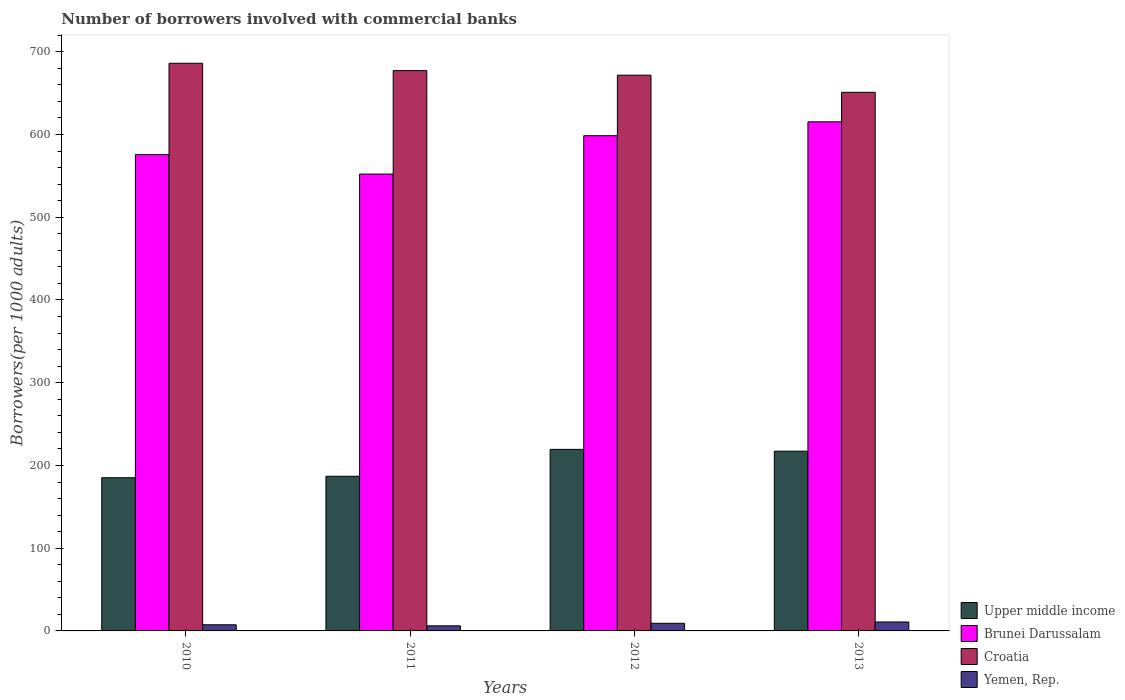How many groups of bars are there?
Provide a succinct answer. 4. Are the number of bars per tick equal to the number of legend labels?
Give a very brief answer. Yes. How many bars are there on the 2nd tick from the right?
Make the answer very short. 4. In how many cases, is the number of bars for a given year not equal to the number of legend labels?
Your answer should be very brief. 0. What is the number of borrowers involved with commercial banks in Yemen, Rep. in 2011?
Provide a succinct answer. 6.14. Across all years, what is the maximum number of borrowers involved with commercial banks in Yemen, Rep.?
Provide a short and direct response. 10.82. Across all years, what is the minimum number of borrowers involved with commercial banks in Croatia?
Give a very brief answer. 651.02. In which year was the number of borrowers involved with commercial banks in Croatia minimum?
Keep it short and to the point. 2013. What is the total number of borrowers involved with commercial banks in Brunei Darussalam in the graph?
Make the answer very short. 2341.93. What is the difference between the number of borrowers involved with commercial banks in Upper middle income in 2010 and that in 2012?
Your answer should be compact. -34.28. What is the difference between the number of borrowers involved with commercial banks in Upper middle income in 2011 and the number of borrowers involved with commercial banks in Brunei Darussalam in 2013?
Keep it short and to the point. -428.42. What is the average number of borrowers involved with commercial banks in Upper middle income per year?
Your answer should be very brief. 202.2. In the year 2010, what is the difference between the number of borrowers involved with commercial banks in Brunei Darussalam and number of borrowers involved with commercial banks in Croatia?
Make the answer very short. -110.42. What is the ratio of the number of borrowers involved with commercial banks in Yemen, Rep. in 2011 to that in 2012?
Your response must be concise. 0.67. Is the number of borrowers involved with commercial banks in Yemen, Rep. in 2010 less than that in 2012?
Give a very brief answer. Yes. Is the difference between the number of borrowers involved with commercial banks in Brunei Darussalam in 2011 and 2012 greater than the difference between the number of borrowers involved with commercial banks in Croatia in 2011 and 2012?
Ensure brevity in your answer.  No. What is the difference between the highest and the second highest number of borrowers involved with commercial banks in Upper middle income?
Your response must be concise. 2.18. What is the difference between the highest and the lowest number of borrowers involved with commercial banks in Upper middle income?
Keep it short and to the point. 34.28. In how many years, is the number of borrowers involved with commercial banks in Yemen, Rep. greater than the average number of borrowers involved with commercial banks in Yemen, Rep. taken over all years?
Provide a succinct answer. 2. What does the 1st bar from the left in 2011 represents?
Your answer should be compact. Upper middle income. What does the 4th bar from the right in 2010 represents?
Offer a terse response. Upper middle income. How many bars are there?
Your answer should be very brief. 16. How many years are there in the graph?
Your response must be concise. 4. Does the graph contain any zero values?
Keep it short and to the point. No. How are the legend labels stacked?
Provide a succinct answer. Vertical. What is the title of the graph?
Ensure brevity in your answer.  Number of borrowers involved with commercial banks. What is the label or title of the X-axis?
Offer a terse response. Years. What is the label or title of the Y-axis?
Give a very brief answer. Borrowers(per 1000 adults). What is the Borrowers(per 1000 adults) of Upper middle income in 2010?
Provide a succinct answer. 185.15. What is the Borrowers(per 1000 adults) of Brunei Darussalam in 2010?
Provide a succinct answer. 575.73. What is the Borrowers(per 1000 adults) in Croatia in 2010?
Provide a succinct answer. 686.15. What is the Borrowers(per 1000 adults) of Yemen, Rep. in 2010?
Offer a terse response. 7.43. What is the Borrowers(per 1000 adults) of Upper middle income in 2011?
Offer a terse response. 186.95. What is the Borrowers(per 1000 adults) of Brunei Darussalam in 2011?
Provide a short and direct response. 552.23. What is the Borrowers(per 1000 adults) in Croatia in 2011?
Ensure brevity in your answer.  677.25. What is the Borrowers(per 1000 adults) of Yemen, Rep. in 2011?
Your answer should be compact. 6.14. What is the Borrowers(per 1000 adults) in Upper middle income in 2012?
Offer a terse response. 219.44. What is the Borrowers(per 1000 adults) in Brunei Darussalam in 2012?
Your answer should be very brief. 598.59. What is the Borrowers(per 1000 adults) in Croatia in 2012?
Ensure brevity in your answer.  671.74. What is the Borrowers(per 1000 adults) of Yemen, Rep. in 2012?
Make the answer very short. 9.23. What is the Borrowers(per 1000 adults) of Upper middle income in 2013?
Offer a very short reply. 217.26. What is the Borrowers(per 1000 adults) in Brunei Darussalam in 2013?
Your response must be concise. 615.37. What is the Borrowers(per 1000 adults) in Croatia in 2013?
Your answer should be very brief. 651.02. What is the Borrowers(per 1000 adults) of Yemen, Rep. in 2013?
Your answer should be very brief. 10.82. Across all years, what is the maximum Borrowers(per 1000 adults) of Upper middle income?
Provide a short and direct response. 219.44. Across all years, what is the maximum Borrowers(per 1000 adults) of Brunei Darussalam?
Your answer should be very brief. 615.37. Across all years, what is the maximum Borrowers(per 1000 adults) in Croatia?
Provide a succinct answer. 686.15. Across all years, what is the maximum Borrowers(per 1000 adults) in Yemen, Rep.?
Your answer should be compact. 10.82. Across all years, what is the minimum Borrowers(per 1000 adults) of Upper middle income?
Your answer should be very brief. 185.15. Across all years, what is the minimum Borrowers(per 1000 adults) in Brunei Darussalam?
Ensure brevity in your answer.  552.23. Across all years, what is the minimum Borrowers(per 1000 adults) in Croatia?
Keep it short and to the point. 651.02. Across all years, what is the minimum Borrowers(per 1000 adults) in Yemen, Rep.?
Keep it short and to the point. 6.14. What is the total Borrowers(per 1000 adults) in Upper middle income in the graph?
Offer a terse response. 808.8. What is the total Borrowers(per 1000 adults) of Brunei Darussalam in the graph?
Provide a short and direct response. 2341.93. What is the total Borrowers(per 1000 adults) of Croatia in the graph?
Offer a very short reply. 2686.16. What is the total Borrowers(per 1000 adults) in Yemen, Rep. in the graph?
Give a very brief answer. 33.62. What is the difference between the Borrowers(per 1000 adults) of Upper middle income in 2010 and that in 2011?
Provide a succinct answer. -1.8. What is the difference between the Borrowers(per 1000 adults) in Brunei Darussalam in 2010 and that in 2011?
Provide a succinct answer. 23.5. What is the difference between the Borrowers(per 1000 adults) of Croatia in 2010 and that in 2011?
Provide a short and direct response. 8.9. What is the difference between the Borrowers(per 1000 adults) in Yemen, Rep. in 2010 and that in 2011?
Provide a succinct answer. 1.29. What is the difference between the Borrowers(per 1000 adults) in Upper middle income in 2010 and that in 2012?
Offer a terse response. -34.28. What is the difference between the Borrowers(per 1000 adults) of Brunei Darussalam in 2010 and that in 2012?
Your answer should be very brief. -22.86. What is the difference between the Borrowers(per 1000 adults) in Croatia in 2010 and that in 2012?
Ensure brevity in your answer.  14.41. What is the difference between the Borrowers(per 1000 adults) of Yemen, Rep. in 2010 and that in 2012?
Offer a terse response. -1.8. What is the difference between the Borrowers(per 1000 adults) of Upper middle income in 2010 and that in 2013?
Give a very brief answer. -32.1. What is the difference between the Borrowers(per 1000 adults) in Brunei Darussalam in 2010 and that in 2013?
Your answer should be very brief. -39.64. What is the difference between the Borrowers(per 1000 adults) in Croatia in 2010 and that in 2013?
Your response must be concise. 35.13. What is the difference between the Borrowers(per 1000 adults) in Yemen, Rep. in 2010 and that in 2013?
Provide a short and direct response. -3.39. What is the difference between the Borrowers(per 1000 adults) of Upper middle income in 2011 and that in 2012?
Your answer should be very brief. -32.48. What is the difference between the Borrowers(per 1000 adults) in Brunei Darussalam in 2011 and that in 2012?
Your answer should be very brief. -46.36. What is the difference between the Borrowers(per 1000 adults) of Croatia in 2011 and that in 2012?
Give a very brief answer. 5.51. What is the difference between the Borrowers(per 1000 adults) of Yemen, Rep. in 2011 and that in 2012?
Your response must be concise. -3.09. What is the difference between the Borrowers(per 1000 adults) of Upper middle income in 2011 and that in 2013?
Give a very brief answer. -30.3. What is the difference between the Borrowers(per 1000 adults) of Brunei Darussalam in 2011 and that in 2013?
Keep it short and to the point. -63.14. What is the difference between the Borrowers(per 1000 adults) of Croatia in 2011 and that in 2013?
Give a very brief answer. 26.23. What is the difference between the Borrowers(per 1000 adults) of Yemen, Rep. in 2011 and that in 2013?
Your answer should be compact. -4.67. What is the difference between the Borrowers(per 1000 adults) of Upper middle income in 2012 and that in 2013?
Your answer should be compact. 2.18. What is the difference between the Borrowers(per 1000 adults) in Brunei Darussalam in 2012 and that in 2013?
Offer a very short reply. -16.78. What is the difference between the Borrowers(per 1000 adults) in Croatia in 2012 and that in 2013?
Provide a short and direct response. 20.72. What is the difference between the Borrowers(per 1000 adults) in Yemen, Rep. in 2012 and that in 2013?
Your answer should be very brief. -1.58. What is the difference between the Borrowers(per 1000 adults) in Upper middle income in 2010 and the Borrowers(per 1000 adults) in Brunei Darussalam in 2011?
Offer a very short reply. -367.08. What is the difference between the Borrowers(per 1000 adults) in Upper middle income in 2010 and the Borrowers(per 1000 adults) in Croatia in 2011?
Ensure brevity in your answer.  -492.09. What is the difference between the Borrowers(per 1000 adults) in Upper middle income in 2010 and the Borrowers(per 1000 adults) in Yemen, Rep. in 2011?
Offer a terse response. 179.01. What is the difference between the Borrowers(per 1000 adults) in Brunei Darussalam in 2010 and the Borrowers(per 1000 adults) in Croatia in 2011?
Your answer should be very brief. -101.51. What is the difference between the Borrowers(per 1000 adults) of Brunei Darussalam in 2010 and the Borrowers(per 1000 adults) of Yemen, Rep. in 2011?
Your response must be concise. 569.59. What is the difference between the Borrowers(per 1000 adults) in Croatia in 2010 and the Borrowers(per 1000 adults) in Yemen, Rep. in 2011?
Your answer should be compact. 680.01. What is the difference between the Borrowers(per 1000 adults) of Upper middle income in 2010 and the Borrowers(per 1000 adults) of Brunei Darussalam in 2012?
Make the answer very short. -413.44. What is the difference between the Borrowers(per 1000 adults) in Upper middle income in 2010 and the Borrowers(per 1000 adults) in Croatia in 2012?
Keep it short and to the point. -486.59. What is the difference between the Borrowers(per 1000 adults) in Upper middle income in 2010 and the Borrowers(per 1000 adults) in Yemen, Rep. in 2012?
Your answer should be very brief. 175.92. What is the difference between the Borrowers(per 1000 adults) of Brunei Darussalam in 2010 and the Borrowers(per 1000 adults) of Croatia in 2012?
Make the answer very short. -96.01. What is the difference between the Borrowers(per 1000 adults) in Brunei Darussalam in 2010 and the Borrowers(per 1000 adults) in Yemen, Rep. in 2012?
Ensure brevity in your answer.  566.5. What is the difference between the Borrowers(per 1000 adults) of Croatia in 2010 and the Borrowers(per 1000 adults) of Yemen, Rep. in 2012?
Give a very brief answer. 676.92. What is the difference between the Borrowers(per 1000 adults) in Upper middle income in 2010 and the Borrowers(per 1000 adults) in Brunei Darussalam in 2013?
Make the answer very short. -430.22. What is the difference between the Borrowers(per 1000 adults) of Upper middle income in 2010 and the Borrowers(per 1000 adults) of Croatia in 2013?
Your answer should be very brief. -465.86. What is the difference between the Borrowers(per 1000 adults) in Upper middle income in 2010 and the Borrowers(per 1000 adults) in Yemen, Rep. in 2013?
Offer a very short reply. 174.34. What is the difference between the Borrowers(per 1000 adults) of Brunei Darussalam in 2010 and the Borrowers(per 1000 adults) of Croatia in 2013?
Provide a succinct answer. -75.28. What is the difference between the Borrowers(per 1000 adults) of Brunei Darussalam in 2010 and the Borrowers(per 1000 adults) of Yemen, Rep. in 2013?
Offer a terse response. 564.92. What is the difference between the Borrowers(per 1000 adults) of Croatia in 2010 and the Borrowers(per 1000 adults) of Yemen, Rep. in 2013?
Your answer should be very brief. 675.33. What is the difference between the Borrowers(per 1000 adults) in Upper middle income in 2011 and the Borrowers(per 1000 adults) in Brunei Darussalam in 2012?
Give a very brief answer. -411.63. What is the difference between the Borrowers(per 1000 adults) in Upper middle income in 2011 and the Borrowers(per 1000 adults) in Croatia in 2012?
Give a very brief answer. -484.79. What is the difference between the Borrowers(per 1000 adults) of Upper middle income in 2011 and the Borrowers(per 1000 adults) of Yemen, Rep. in 2012?
Provide a succinct answer. 177.72. What is the difference between the Borrowers(per 1000 adults) of Brunei Darussalam in 2011 and the Borrowers(per 1000 adults) of Croatia in 2012?
Provide a short and direct response. -119.51. What is the difference between the Borrowers(per 1000 adults) of Brunei Darussalam in 2011 and the Borrowers(per 1000 adults) of Yemen, Rep. in 2012?
Your response must be concise. 543. What is the difference between the Borrowers(per 1000 adults) of Croatia in 2011 and the Borrowers(per 1000 adults) of Yemen, Rep. in 2012?
Offer a very short reply. 668.01. What is the difference between the Borrowers(per 1000 adults) of Upper middle income in 2011 and the Borrowers(per 1000 adults) of Brunei Darussalam in 2013?
Offer a terse response. -428.42. What is the difference between the Borrowers(per 1000 adults) of Upper middle income in 2011 and the Borrowers(per 1000 adults) of Croatia in 2013?
Your answer should be compact. -464.06. What is the difference between the Borrowers(per 1000 adults) of Upper middle income in 2011 and the Borrowers(per 1000 adults) of Yemen, Rep. in 2013?
Give a very brief answer. 176.14. What is the difference between the Borrowers(per 1000 adults) in Brunei Darussalam in 2011 and the Borrowers(per 1000 adults) in Croatia in 2013?
Your response must be concise. -98.78. What is the difference between the Borrowers(per 1000 adults) of Brunei Darussalam in 2011 and the Borrowers(per 1000 adults) of Yemen, Rep. in 2013?
Provide a short and direct response. 541.42. What is the difference between the Borrowers(per 1000 adults) in Croatia in 2011 and the Borrowers(per 1000 adults) in Yemen, Rep. in 2013?
Your answer should be compact. 666.43. What is the difference between the Borrowers(per 1000 adults) in Upper middle income in 2012 and the Borrowers(per 1000 adults) in Brunei Darussalam in 2013?
Ensure brevity in your answer.  -395.94. What is the difference between the Borrowers(per 1000 adults) of Upper middle income in 2012 and the Borrowers(per 1000 adults) of Croatia in 2013?
Your response must be concise. -431.58. What is the difference between the Borrowers(per 1000 adults) of Upper middle income in 2012 and the Borrowers(per 1000 adults) of Yemen, Rep. in 2013?
Offer a very short reply. 208.62. What is the difference between the Borrowers(per 1000 adults) in Brunei Darussalam in 2012 and the Borrowers(per 1000 adults) in Croatia in 2013?
Your answer should be compact. -52.43. What is the difference between the Borrowers(per 1000 adults) in Brunei Darussalam in 2012 and the Borrowers(per 1000 adults) in Yemen, Rep. in 2013?
Ensure brevity in your answer.  587.77. What is the difference between the Borrowers(per 1000 adults) of Croatia in 2012 and the Borrowers(per 1000 adults) of Yemen, Rep. in 2013?
Provide a succinct answer. 660.92. What is the average Borrowers(per 1000 adults) of Upper middle income per year?
Offer a very short reply. 202.2. What is the average Borrowers(per 1000 adults) of Brunei Darussalam per year?
Keep it short and to the point. 585.48. What is the average Borrowers(per 1000 adults) in Croatia per year?
Make the answer very short. 671.54. What is the average Borrowers(per 1000 adults) in Yemen, Rep. per year?
Offer a very short reply. 8.41. In the year 2010, what is the difference between the Borrowers(per 1000 adults) in Upper middle income and Borrowers(per 1000 adults) in Brunei Darussalam?
Make the answer very short. -390.58. In the year 2010, what is the difference between the Borrowers(per 1000 adults) of Upper middle income and Borrowers(per 1000 adults) of Croatia?
Provide a short and direct response. -501. In the year 2010, what is the difference between the Borrowers(per 1000 adults) in Upper middle income and Borrowers(per 1000 adults) in Yemen, Rep.?
Ensure brevity in your answer.  177.72. In the year 2010, what is the difference between the Borrowers(per 1000 adults) of Brunei Darussalam and Borrowers(per 1000 adults) of Croatia?
Ensure brevity in your answer.  -110.42. In the year 2010, what is the difference between the Borrowers(per 1000 adults) in Brunei Darussalam and Borrowers(per 1000 adults) in Yemen, Rep.?
Offer a very short reply. 568.3. In the year 2010, what is the difference between the Borrowers(per 1000 adults) of Croatia and Borrowers(per 1000 adults) of Yemen, Rep.?
Make the answer very short. 678.72. In the year 2011, what is the difference between the Borrowers(per 1000 adults) of Upper middle income and Borrowers(per 1000 adults) of Brunei Darussalam?
Your answer should be compact. -365.28. In the year 2011, what is the difference between the Borrowers(per 1000 adults) in Upper middle income and Borrowers(per 1000 adults) in Croatia?
Provide a succinct answer. -490.29. In the year 2011, what is the difference between the Borrowers(per 1000 adults) of Upper middle income and Borrowers(per 1000 adults) of Yemen, Rep.?
Give a very brief answer. 180.81. In the year 2011, what is the difference between the Borrowers(per 1000 adults) in Brunei Darussalam and Borrowers(per 1000 adults) in Croatia?
Offer a terse response. -125.01. In the year 2011, what is the difference between the Borrowers(per 1000 adults) of Brunei Darussalam and Borrowers(per 1000 adults) of Yemen, Rep.?
Provide a short and direct response. 546.09. In the year 2011, what is the difference between the Borrowers(per 1000 adults) in Croatia and Borrowers(per 1000 adults) in Yemen, Rep.?
Your answer should be compact. 671.1. In the year 2012, what is the difference between the Borrowers(per 1000 adults) in Upper middle income and Borrowers(per 1000 adults) in Brunei Darussalam?
Your response must be concise. -379.15. In the year 2012, what is the difference between the Borrowers(per 1000 adults) in Upper middle income and Borrowers(per 1000 adults) in Croatia?
Your answer should be compact. -452.3. In the year 2012, what is the difference between the Borrowers(per 1000 adults) of Upper middle income and Borrowers(per 1000 adults) of Yemen, Rep.?
Ensure brevity in your answer.  210.21. In the year 2012, what is the difference between the Borrowers(per 1000 adults) in Brunei Darussalam and Borrowers(per 1000 adults) in Croatia?
Your answer should be compact. -73.15. In the year 2012, what is the difference between the Borrowers(per 1000 adults) in Brunei Darussalam and Borrowers(per 1000 adults) in Yemen, Rep.?
Keep it short and to the point. 589.36. In the year 2012, what is the difference between the Borrowers(per 1000 adults) in Croatia and Borrowers(per 1000 adults) in Yemen, Rep.?
Your response must be concise. 662.51. In the year 2013, what is the difference between the Borrowers(per 1000 adults) of Upper middle income and Borrowers(per 1000 adults) of Brunei Darussalam?
Offer a very short reply. -398.12. In the year 2013, what is the difference between the Borrowers(per 1000 adults) of Upper middle income and Borrowers(per 1000 adults) of Croatia?
Make the answer very short. -433.76. In the year 2013, what is the difference between the Borrowers(per 1000 adults) of Upper middle income and Borrowers(per 1000 adults) of Yemen, Rep.?
Your response must be concise. 206.44. In the year 2013, what is the difference between the Borrowers(per 1000 adults) of Brunei Darussalam and Borrowers(per 1000 adults) of Croatia?
Offer a very short reply. -35.64. In the year 2013, what is the difference between the Borrowers(per 1000 adults) of Brunei Darussalam and Borrowers(per 1000 adults) of Yemen, Rep.?
Offer a terse response. 604.56. In the year 2013, what is the difference between the Borrowers(per 1000 adults) in Croatia and Borrowers(per 1000 adults) in Yemen, Rep.?
Offer a terse response. 640.2. What is the ratio of the Borrowers(per 1000 adults) of Brunei Darussalam in 2010 to that in 2011?
Offer a very short reply. 1.04. What is the ratio of the Borrowers(per 1000 adults) of Croatia in 2010 to that in 2011?
Provide a short and direct response. 1.01. What is the ratio of the Borrowers(per 1000 adults) of Yemen, Rep. in 2010 to that in 2011?
Offer a terse response. 1.21. What is the ratio of the Borrowers(per 1000 adults) in Upper middle income in 2010 to that in 2012?
Provide a succinct answer. 0.84. What is the ratio of the Borrowers(per 1000 adults) in Brunei Darussalam in 2010 to that in 2012?
Give a very brief answer. 0.96. What is the ratio of the Borrowers(per 1000 adults) in Croatia in 2010 to that in 2012?
Your answer should be very brief. 1.02. What is the ratio of the Borrowers(per 1000 adults) of Yemen, Rep. in 2010 to that in 2012?
Offer a terse response. 0.8. What is the ratio of the Borrowers(per 1000 adults) of Upper middle income in 2010 to that in 2013?
Offer a very short reply. 0.85. What is the ratio of the Borrowers(per 1000 adults) of Brunei Darussalam in 2010 to that in 2013?
Your answer should be compact. 0.94. What is the ratio of the Borrowers(per 1000 adults) in Croatia in 2010 to that in 2013?
Ensure brevity in your answer.  1.05. What is the ratio of the Borrowers(per 1000 adults) of Yemen, Rep. in 2010 to that in 2013?
Provide a short and direct response. 0.69. What is the ratio of the Borrowers(per 1000 adults) of Upper middle income in 2011 to that in 2012?
Give a very brief answer. 0.85. What is the ratio of the Borrowers(per 1000 adults) of Brunei Darussalam in 2011 to that in 2012?
Your answer should be compact. 0.92. What is the ratio of the Borrowers(per 1000 adults) of Croatia in 2011 to that in 2012?
Offer a very short reply. 1.01. What is the ratio of the Borrowers(per 1000 adults) in Yemen, Rep. in 2011 to that in 2012?
Offer a very short reply. 0.67. What is the ratio of the Borrowers(per 1000 adults) of Upper middle income in 2011 to that in 2013?
Your answer should be compact. 0.86. What is the ratio of the Borrowers(per 1000 adults) of Brunei Darussalam in 2011 to that in 2013?
Give a very brief answer. 0.9. What is the ratio of the Borrowers(per 1000 adults) in Croatia in 2011 to that in 2013?
Your answer should be very brief. 1.04. What is the ratio of the Borrowers(per 1000 adults) in Yemen, Rep. in 2011 to that in 2013?
Make the answer very short. 0.57. What is the ratio of the Borrowers(per 1000 adults) of Brunei Darussalam in 2012 to that in 2013?
Your response must be concise. 0.97. What is the ratio of the Borrowers(per 1000 adults) of Croatia in 2012 to that in 2013?
Your response must be concise. 1.03. What is the ratio of the Borrowers(per 1000 adults) in Yemen, Rep. in 2012 to that in 2013?
Ensure brevity in your answer.  0.85. What is the difference between the highest and the second highest Borrowers(per 1000 adults) in Upper middle income?
Offer a terse response. 2.18. What is the difference between the highest and the second highest Borrowers(per 1000 adults) in Brunei Darussalam?
Provide a succinct answer. 16.78. What is the difference between the highest and the second highest Borrowers(per 1000 adults) of Croatia?
Provide a succinct answer. 8.9. What is the difference between the highest and the second highest Borrowers(per 1000 adults) in Yemen, Rep.?
Make the answer very short. 1.58. What is the difference between the highest and the lowest Borrowers(per 1000 adults) in Upper middle income?
Your answer should be compact. 34.28. What is the difference between the highest and the lowest Borrowers(per 1000 adults) in Brunei Darussalam?
Your answer should be very brief. 63.14. What is the difference between the highest and the lowest Borrowers(per 1000 adults) of Croatia?
Offer a very short reply. 35.13. What is the difference between the highest and the lowest Borrowers(per 1000 adults) in Yemen, Rep.?
Offer a very short reply. 4.67. 